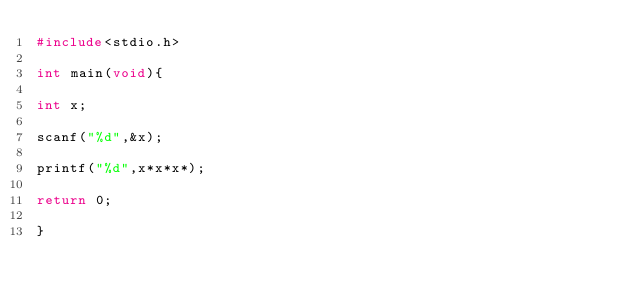Convert code to text. <code><loc_0><loc_0><loc_500><loc_500><_C_>#include<stdio.h>

int main(void){

int x;

scanf("%d",&x);

printf("%d",x*x*x*);

return 0;

}</code> 